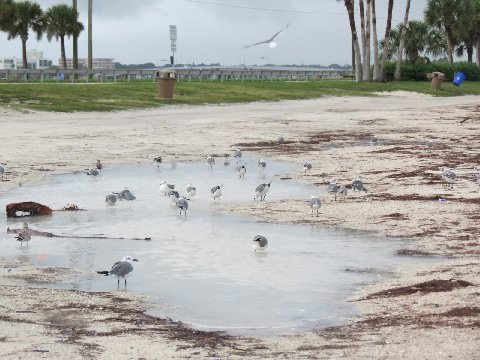Describe the objects in this image and their specific colors. I can see bird in darkgreen, lightgray, darkgray, and gray tones, bird in darkgreen, gray, darkgray, and lightgray tones, bird in darkgreen, lightgray, darkgray, and gray tones, bird in darkgreen, darkgray, lightgray, and gray tones, and bird in darkgreen, darkgray, lightgray, and gray tones in this image. 